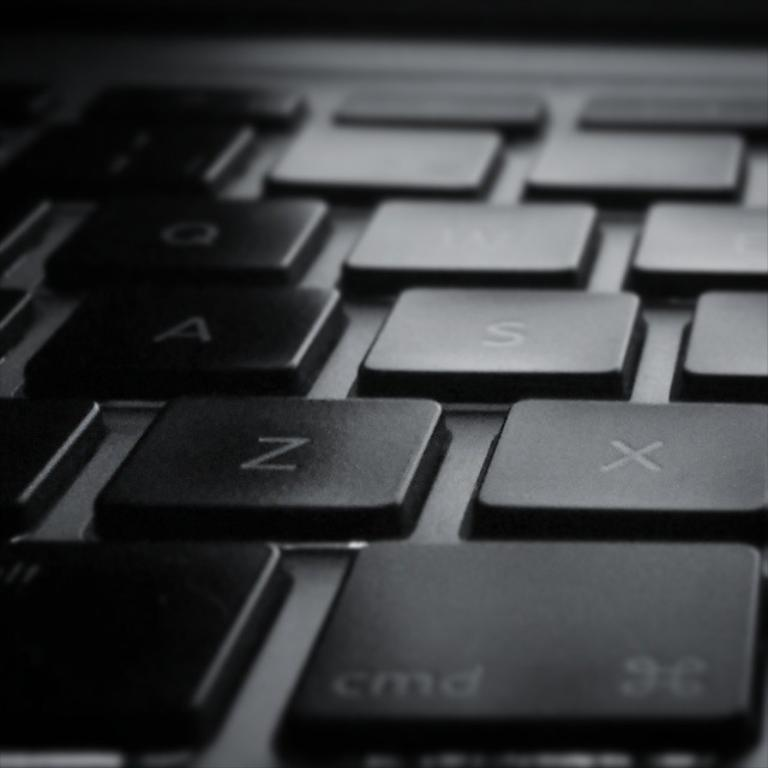<image>
Render a clear and concise summary of the photo. A laptop's black keys are shown with the letters Z and X are visible. 